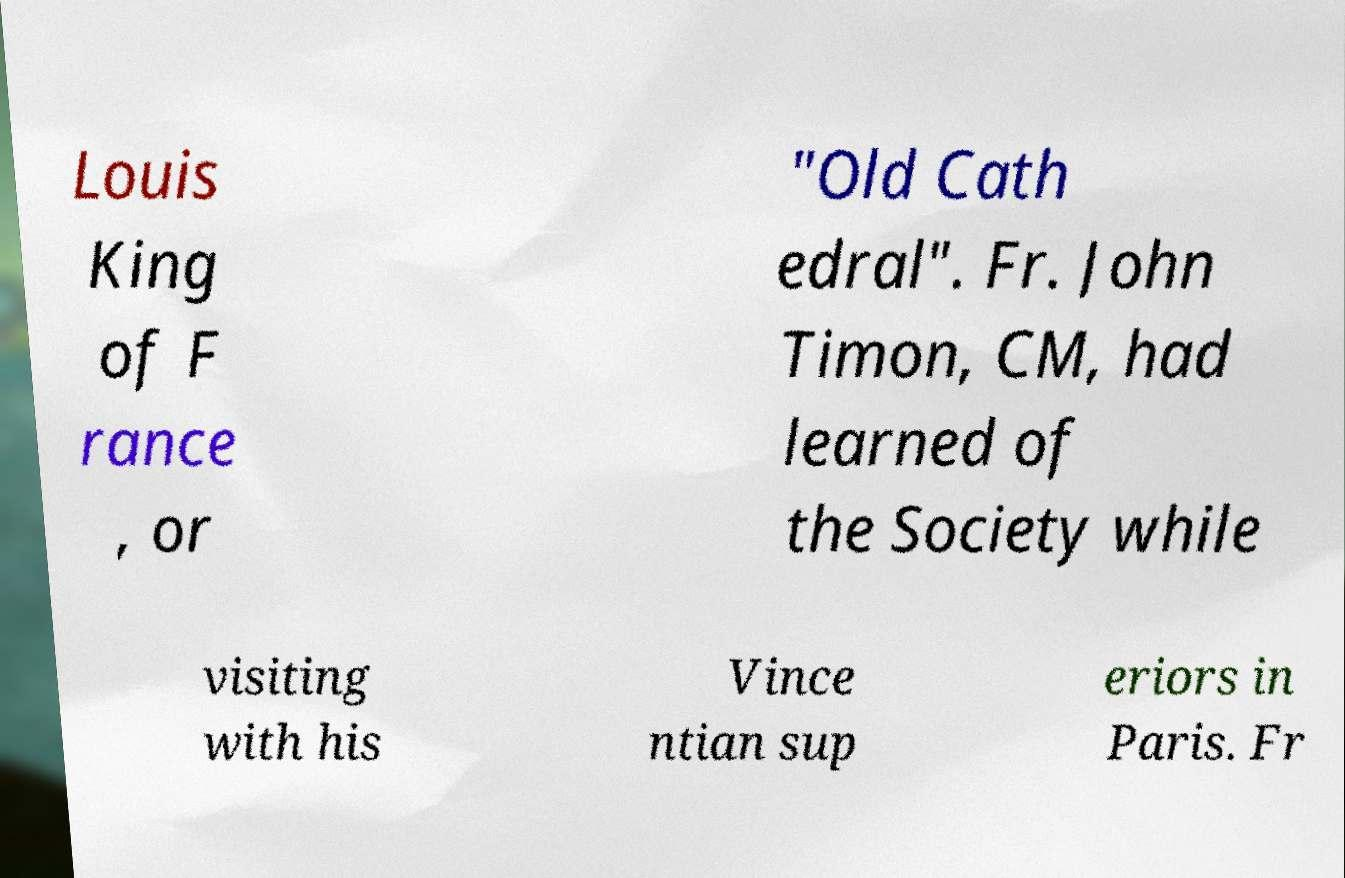Can you accurately transcribe the text from the provided image for me? Louis King of F rance , or "Old Cath edral". Fr. John Timon, CM, had learned of the Society while visiting with his Vince ntian sup eriors in Paris. Fr 